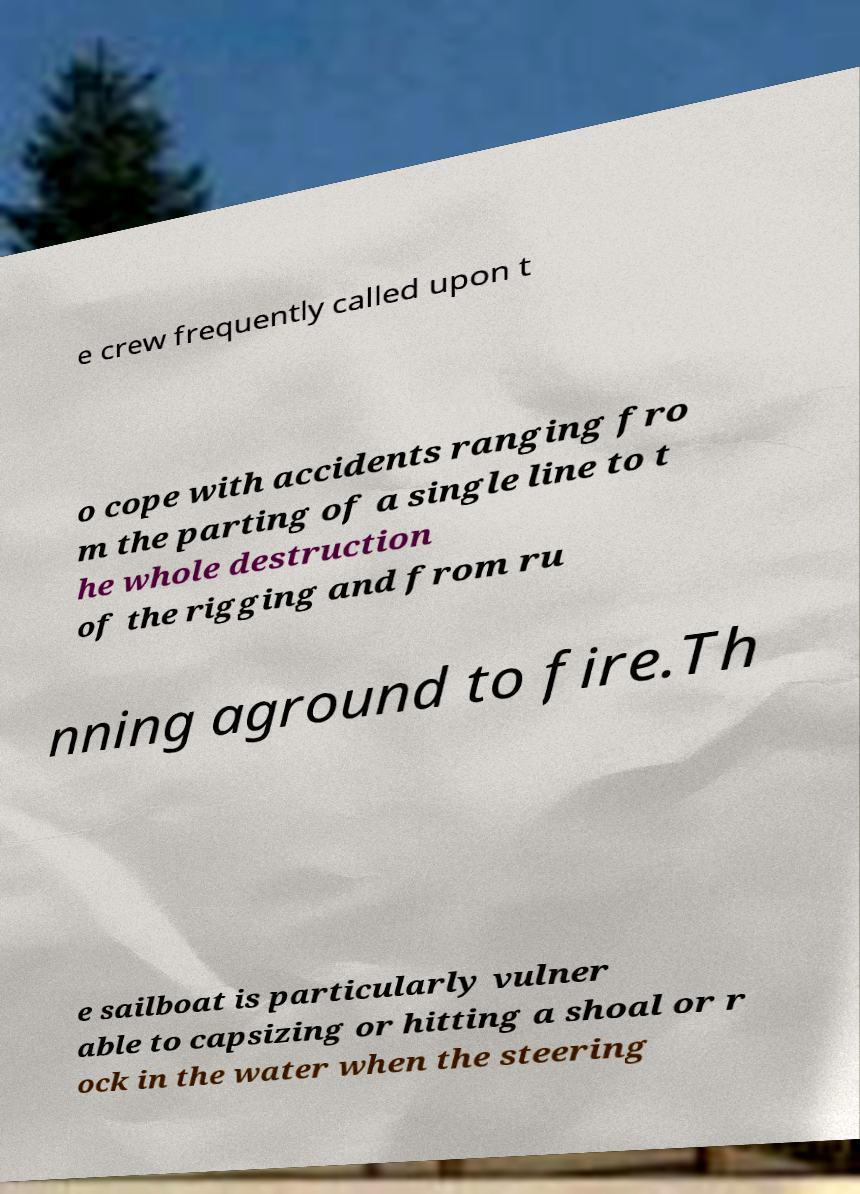Could you extract and type out the text from this image? e crew frequently called upon t o cope with accidents ranging fro m the parting of a single line to t he whole destruction of the rigging and from ru nning aground to fire.Th e sailboat is particularly vulner able to capsizing or hitting a shoal or r ock in the water when the steering 